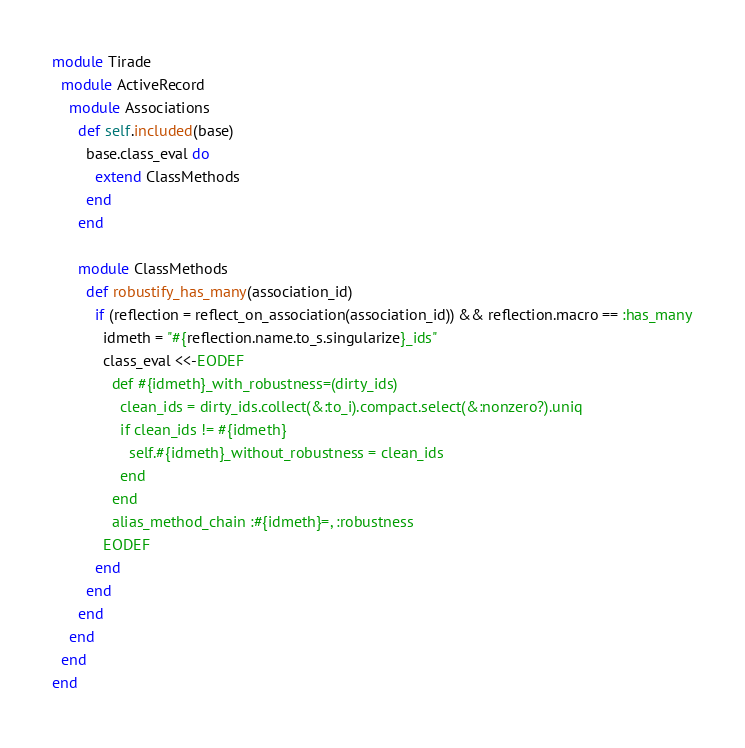<code> <loc_0><loc_0><loc_500><loc_500><_Ruby_>module Tirade
  module ActiveRecord
    module Associations
      def self.included(base)
        base.class_eval do
          extend ClassMethods
        end
      end

      module ClassMethods
        def robustify_has_many(association_id)
          if (reflection = reflect_on_association(association_id)) && reflection.macro == :has_many
            idmeth = "#{reflection.name.to_s.singularize}_ids"
            class_eval <<-EODEF
              def #{idmeth}_with_robustness=(dirty_ids)
                clean_ids = dirty_ids.collect(&:to_i).compact.select(&:nonzero?).uniq
                if clean_ids != #{idmeth}
                  self.#{idmeth}_without_robustness = clean_ids
                end
              end
              alias_method_chain :#{idmeth}=, :robustness
            EODEF
          end
        end
      end
    end
  end
end
</code> 